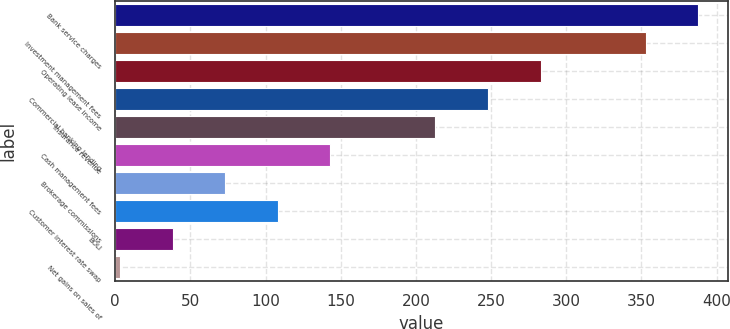Convert chart. <chart><loc_0><loc_0><loc_500><loc_500><bar_chart><fcel>Bank service charges<fcel>Investment management fees<fcel>Operating lease income<fcel>Commercial banking lending<fcel>Insurance revenue<fcel>Cash management fees<fcel>Brokerage commissions<fcel>Customer interest rate swap<fcel>BOLI<fcel>Net gains on sales of<nl><fcel>387.87<fcel>352.9<fcel>282.96<fcel>247.99<fcel>213.02<fcel>143.08<fcel>73.14<fcel>108.11<fcel>38.17<fcel>3.2<nl></chart> 